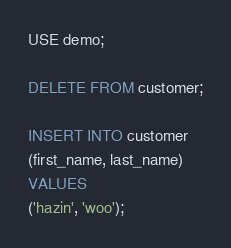Convert code to text. <code><loc_0><loc_0><loc_500><loc_500><_SQL_>USE demo;

DELETE FROM customer;

INSERT INTO customer
(first_name, last_name)
VALUES
('hazin', 'woo');
</code> 